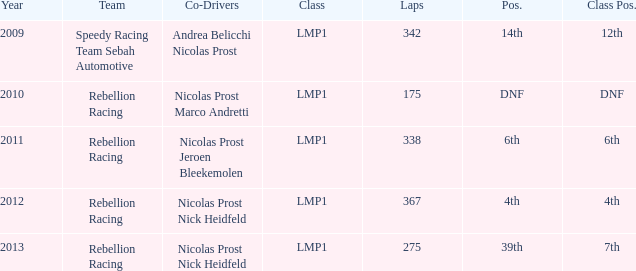What is class position, when year is pre-2013, and when laps surpass 175? 12th, 6th, 4th. 